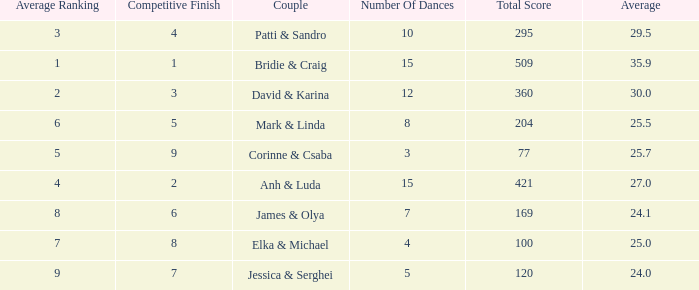What is the average for the couple anh & luda? 27.0. 